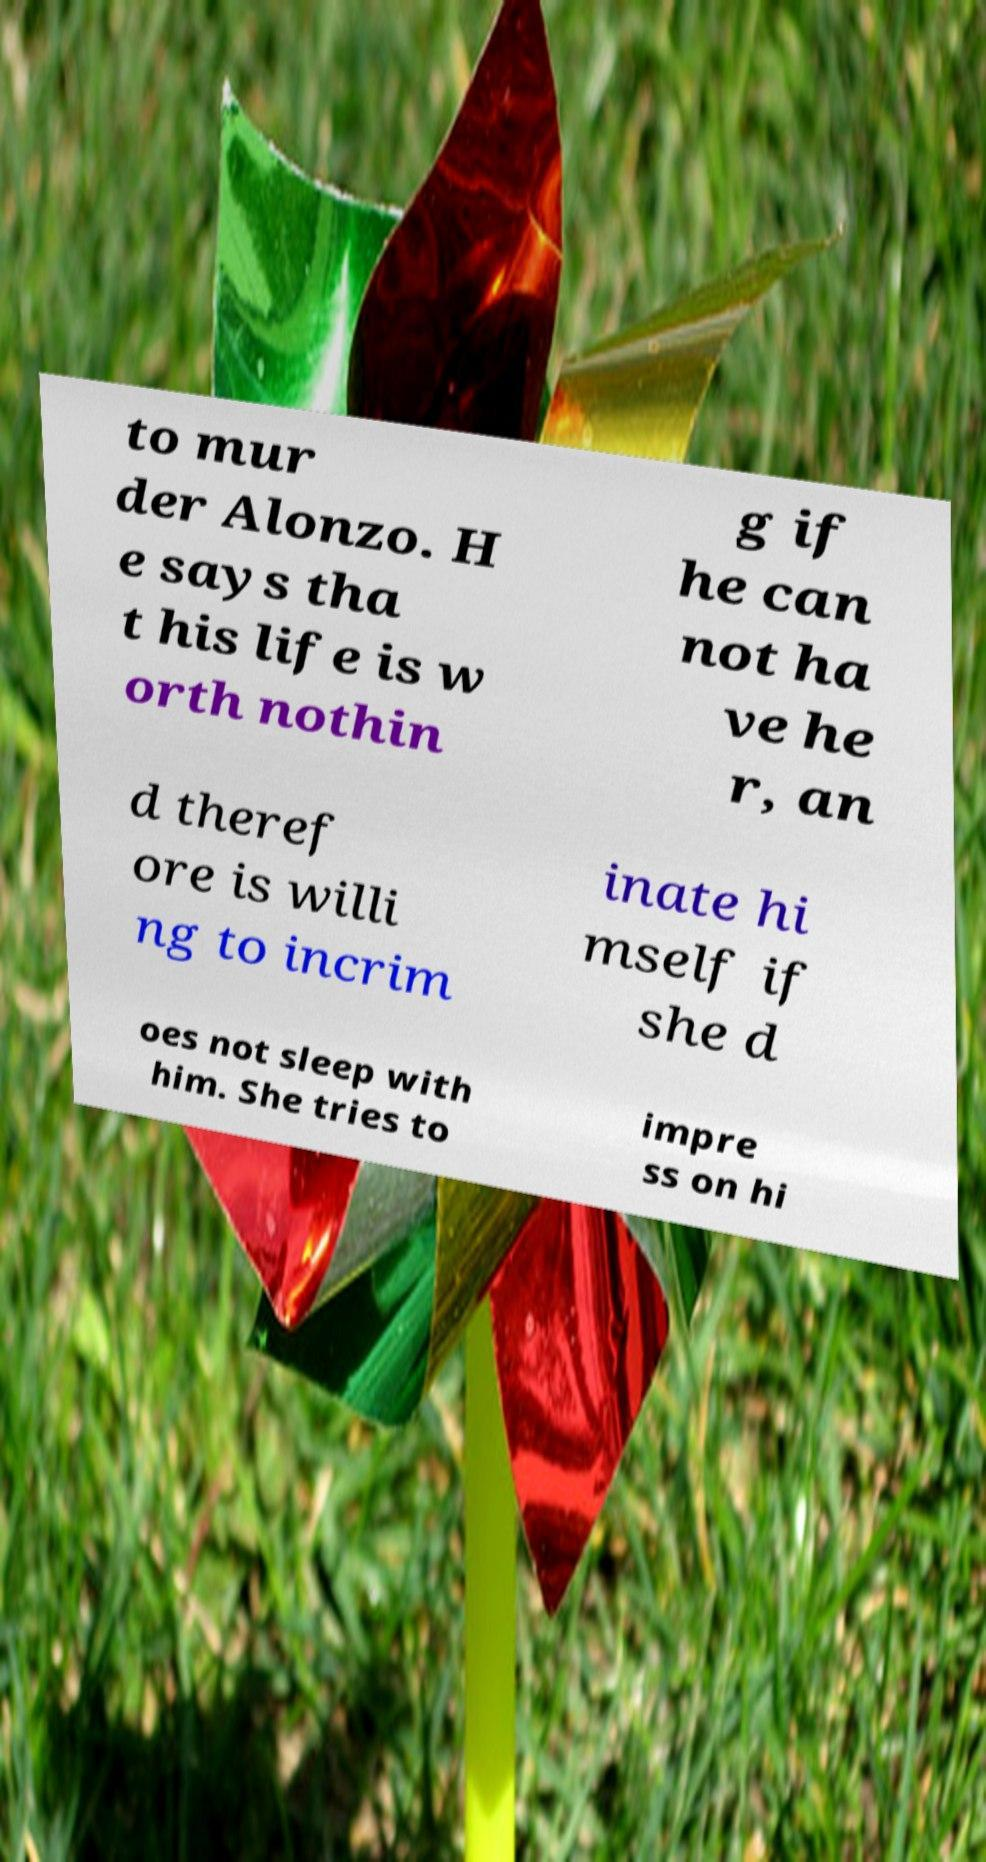What messages or text are displayed in this image? I need them in a readable, typed format. to mur der Alonzo. H e says tha t his life is w orth nothin g if he can not ha ve he r, an d theref ore is willi ng to incrim inate hi mself if she d oes not sleep with him. She tries to impre ss on hi 